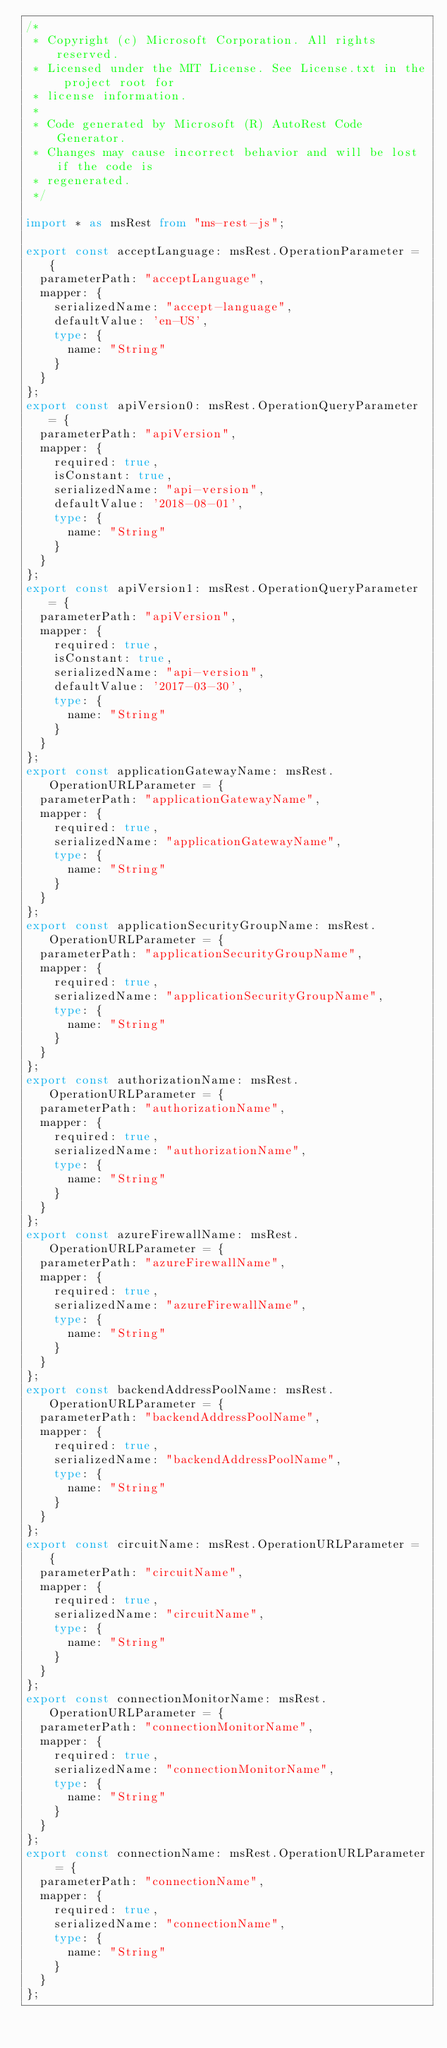<code> <loc_0><loc_0><loc_500><loc_500><_TypeScript_>/*
 * Copyright (c) Microsoft Corporation. All rights reserved.
 * Licensed under the MIT License. See License.txt in the project root for
 * license information.
 *
 * Code generated by Microsoft (R) AutoRest Code Generator.
 * Changes may cause incorrect behavior and will be lost if the code is
 * regenerated.
 */

import * as msRest from "ms-rest-js";

export const acceptLanguage: msRest.OperationParameter = {
  parameterPath: "acceptLanguage",
  mapper: {
    serializedName: "accept-language",
    defaultValue: 'en-US',
    type: {
      name: "String"
    }
  }
};
export const apiVersion0: msRest.OperationQueryParameter = {
  parameterPath: "apiVersion",
  mapper: {
    required: true,
    isConstant: true,
    serializedName: "api-version",
    defaultValue: '2018-08-01',
    type: {
      name: "String"
    }
  }
};
export const apiVersion1: msRest.OperationQueryParameter = {
  parameterPath: "apiVersion",
  mapper: {
    required: true,
    isConstant: true,
    serializedName: "api-version",
    defaultValue: '2017-03-30',
    type: {
      name: "String"
    }
  }
};
export const applicationGatewayName: msRest.OperationURLParameter = {
  parameterPath: "applicationGatewayName",
  mapper: {
    required: true,
    serializedName: "applicationGatewayName",
    type: {
      name: "String"
    }
  }
};
export const applicationSecurityGroupName: msRest.OperationURLParameter = {
  parameterPath: "applicationSecurityGroupName",
  mapper: {
    required: true,
    serializedName: "applicationSecurityGroupName",
    type: {
      name: "String"
    }
  }
};
export const authorizationName: msRest.OperationURLParameter = {
  parameterPath: "authorizationName",
  mapper: {
    required: true,
    serializedName: "authorizationName",
    type: {
      name: "String"
    }
  }
};
export const azureFirewallName: msRest.OperationURLParameter = {
  parameterPath: "azureFirewallName",
  mapper: {
    required: true,
    serializedName: "azureFirewallName",
    type: {
      name: "String"
    }
  }
};
export const backendAddressPoolName: msRest.OperationURLParameter = {
  parameterPath: "backendAddressPoolName",
  mapper: {
    required: true,
    serializedName: "backendAddressPoolName",
    type: {
      name: "String"
    }
  }
};
export const circuitName: msRest.OperationURLParameter = {
  parameterPath: "circuitName",
  mapper: {
    required: true,
    serializedName: "circuitName",
    type: {
      name: "String"
    }
  }
};
export const connectionMonitorName: msRest.OperationURLParameter = {
  parameterPath: "connectionMonitorName",
  mapper: {
    required: true,
    serializedName: "connectionMonitorName",
    type: {
      name: "String"
    }
  }
};
export const connectionName: msRest.OperationURLParameter = {
  parameterPath: "connectionName",
  mapper: {
    required: true,
    serializedName: "connectionName",
    type: {
      name: "String"
    }
  }
};</code> 